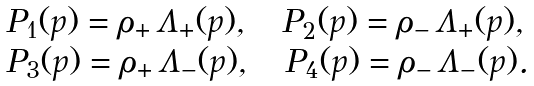<formula> <loc_0><loc_0><loc_500><loc_500>\begin{array} { l } P _ { 1 } ( p ) = \rho _ { + } \, \Lambda _ { + } ( p ) , \quad P _ { 2 } ( p ) = \rho _ { - } \, \Lambda _ { + } ( p ) , \\ P _ { 3 } ( p ) = \rho _ { + } \, \Lambda _ { - } ( p ) , \quad P _ { 4 } ( p ) = \rho _ { - } \, \Lambda _ { - } ( p ) . \end{array}</formula> 